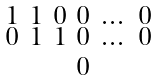Convert formula to latex. <formula><loc_0><loc_0><loc_500><loc_500>\begin{smallmatrix} 1 & 1 & 0 & 0 & \dots & 0 \\ 0 & 1 & 1 & 0 & \dots & 0 \\ \ \\ & & & 0 & \\ \ \end{smallmatrix}</formula> 